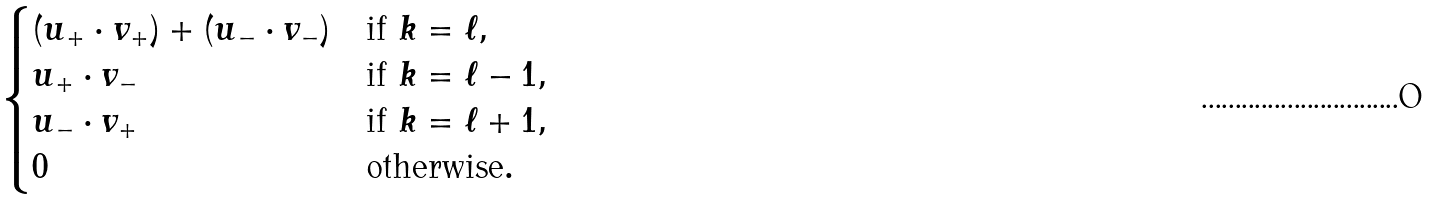<formula> <loc_0><loc_0><loc_500><loc_500>\begin{cases} ( u _ { + } \cdot v _ { + } ) + ( u _ { - } \cdot v _ { - } ) & \text {if } k = \ell , \\ u _ { + } \cdot v _ { - } & \text {if } k = \ell - 1 , \\ u _ { - } \cdot v _ { + } & \text {if } k = \ell + 1 , \\ 0 & \text {otherwise} . \end{cases}</formula> 